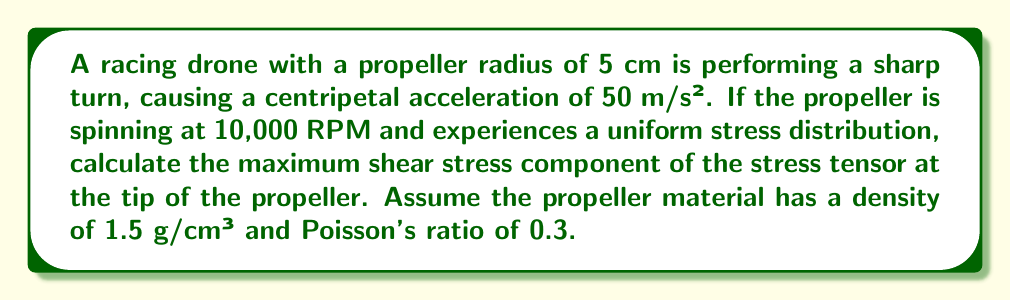What is the answer to this math problem? Let's approach this step-by-step:

1) First, we need to calculate the angular velocity of the propeller:
   $$ \omega = 10,000 \text{ RPM} \times \frac{2\pi}{60 \text{ s}} = 1047.2 \text{ rad/s} $$

2) The centrifugal force per unit volume at the tip of the propeller is:
   $$ f_c = \rho r \omega^2 $$
   where $\rho$ is the density, $r$ is the radius, and $\omega$ is the angular velocity.

3) Calculate $f_c$:
   $$ f_c = 1500 \text{ kg/m}^3 \times 0.05 \text{ m} \times (1047.2 \text{ rad/s})^2 = 8.22 \times 10^7 \text{ N/m}^3 $$

4) The normal stress due to this centrifugal force is:
   $$ \sigma_r = f_c r = 8.22 \times 10^7 \text{ N/m}^3 \times 0.05 \text{ m} = 4.11 \times 10^6 \text{ Pa} $$

5) The additional stress due to the centripetal acceleration during the turn:
   $$ \sigma_a = \rho a r = 1500 \text{ kg/m}^3 \times 50 \text{ m/s}^2 \times 0.05 \text{ m} = 3750 \text{ Pa} $$

6) The total normal stress in the radial direction:
   $$ \sigma_{total} = \sigma_r + \sigma_a = 4.11 \times 10^6 \text{ Pa} + 3750 \text{ Pa} \approx 4.11 \times 10^6 \text{ Pa} $$

7) In a state of pure shear, the maximum shear stress is half the difference between the maximum and minimum principal stresses. Here, $\sigma_{total}$ is our maximum principal stress, and the minimum principal stress is zero (assuming no compression in other directions).

8) Therefore, the maximum shear stress is:
   $$ \tau_{max} = \frac{\sigma_{total}}{2} = \frac{4.11 \times 10^6}{2} = 2.055 \times 10^6 \text{ Pa} $$

This $\tau_{max}$ represents the maximum shear stress component of the stress tensor at the tip of the propeller.
Answer: $2.055 \times 10^6 \text{ Pa}$ 